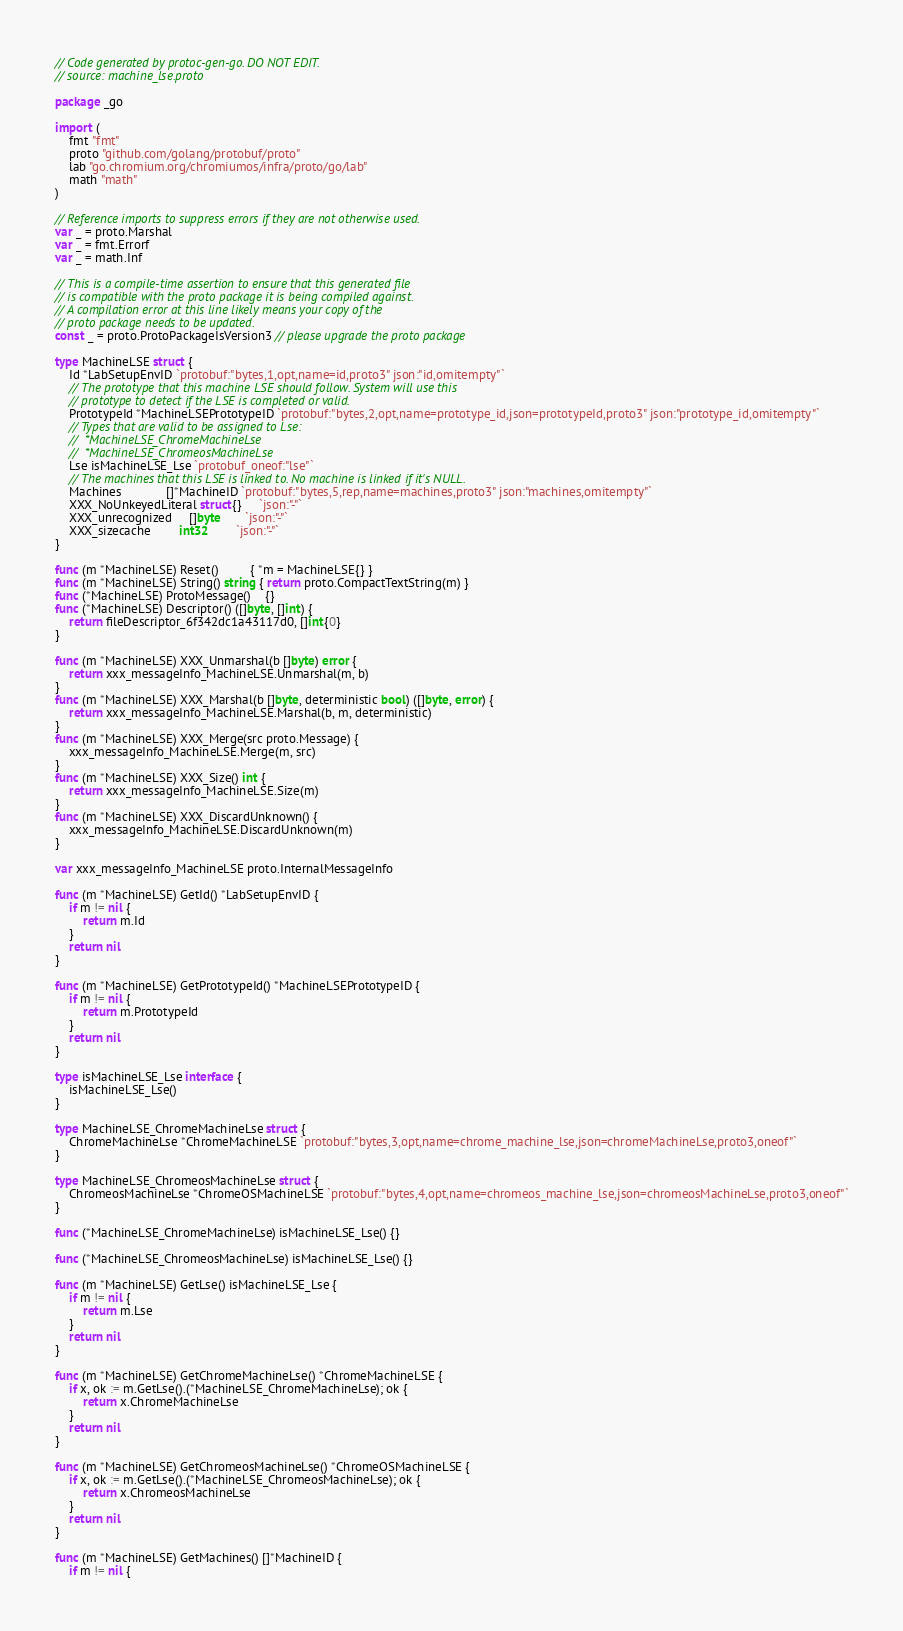Convert code to text. <code><loc_0><loc_0><loc_500><loc_500><_Go_>// Code generated by protoc-gen-go. DO NOT EDIT.
// source: machine_lse.proto

package _go

import (
	fmt "fmt"
	proto "github.com/golang/protobuf/proto"
	lab "go.chromium.org/chromiumos/infra/proto/go/lab"
	math "math"
)

// Reference imports to suppress errors if they are not otherwise used.
var _ = proto.Marshal
var _ = fmt.Errorf
var _ = math.Inf

// This is a compile-time assertion to ensure that this generated file
// is compatible with the proto package it is being compiled against.
// A compilation error at this line likely means your copy of the
// proto package needs to be updated.
const _ = proto.ProtoPackageIsVersion3 // please upgrade the proto package

type MachineLSE struct {
	Id *LabSetupEnvID `protobuf:"bytes,1,opt,name=id,proto3" json:"id,omitempty"`
	// The prototype that this machine LSE should follow. System will use this
	// prototype to detect if the LSE is completed or valid.
	PrototypeId *MachineLSEPrototypeID `protobuf:"bytes,2,opt,name=prototype_id,json=prototypeId,proto3" json:"prototype_id,omitempty"`
	// Types that are valid to be assigned to Lse:
	//	*MachineLSE_ChromeMachineLse
	//	*MachineLSE_ChromeosMachineLse
	Lse isMachineLSE_Lse `protobuf_oneof:"lse"`
	// The machines that this LSE is linked to. No machine is linked if it's NULL.
	Machines             []*MachineID `protobuf:"bytes,5,rep,name=machines,proto3" json:"machines,omitempty"`
	XXX_NoUnkeyedLiteral struct{}     `json:"-"`
	XXX_unrecognized     []byte       `json:"-"`
	XXX_sizecache        int32        `json:"-"`
}

func (m *MachineLSE) Reset()         { *m = MachineLSE{} }
func (m *MachineLSE) String() string { return proto.CompactTextString(m) }
func (*MachineLSE) ProtoMessage()    {}
func (*MachineLSE) Descriptor() ([]byte, []int) {
	return fileDescriptor_6f342dc1a43117d0, []int{0}
}

func (m *MachineLSE) XXX_Unmarshal(b []byte) error {
	return xxx_messageInfo_MachineLSE.Unmarshal(m, b)
}
func (m *MachineLSE) XXX_Marshal(b []byte, deterministic bool) ([]byte, error) {
	return xxx_messageInfo_MachineLSE.Marshal(b, m, deterministic)
}
func (m *MachineLSE) XXX_Merge(src proto.Message) {
	xxx_messageInfo_MachineLSE.Merge(m, src)
}
func (m *MachineLSE) XXX_Size() int {
	return xxx_messageInfo_MachineLSE.Size(m)
}
func (m *MachineLSE) XXX_DiscardUnknown() {
	xxx_messageInfo_MachineLSE.DiscardUnknown(m)
}

var xxx_messageInfo_MachineLSE proto.InternalMessageInfo

func (m *MachineLSE) GetId() *LabSetupEnvID {
	if m != nil {
		return m.Id
	}
	return nil
}

func (m *MachineLSE) GetPrototypeId() *MachineLSEPrototypeID {
	if m != nil {
		return m.PrototypeId
	}
	return nil
}

type isMachineLSE_Lse interface {
	isMachineLSE_Lse()
}

type MachineLSE_ChromeMachineLse struct {
	ChromeMachineLse *ChromeMachineLSE `protobuf:"bytes,3,opt,name=chrome_machine_lse,json=chromeMachineLse,proto3,oneof"`
}

type MachineLSE_ChromeosMachineLse struct {
	ChromeosMachineLse *ChromeOSMachineLSE `protobuf:"bytes,4,opt,name=chromeos_machine_lse,json=chromeosMachineLse,proto3,oneof"`
}

func (*MachineLSE_ChromeMachineLse) isMachineLSE_Lse() {}

func (*MachineLSE_ChromeosMachineLse) isMachineLSE_Lse() {}

func (m *MachineLSE) GetLse() isMachineLSE_Lse {
	if m != nil {
		return m.Lse
	}
	return nil
}

func (m *MachineLSE) GetChromeMachineLse() *ChromeMachineLSE {
	if x, ok := m.GetLse().(*MachineLSE_ChromeMachineLse); ok {
		return x.ChromeMachineLse
	}
	return nil
}

func (m *MachineLSE) GetChromeosMachineLse() *ChromeOSMachineLSE {
	if x, ok := m.GetLse().(*MachineLSE_ChromeosMachineLse); ok {
		return x.ChromeosMachineLse
	}
	return nil
}

func (m *MachineLSE) GetMachines() []*MachineID {
	if m != nil {</code> 